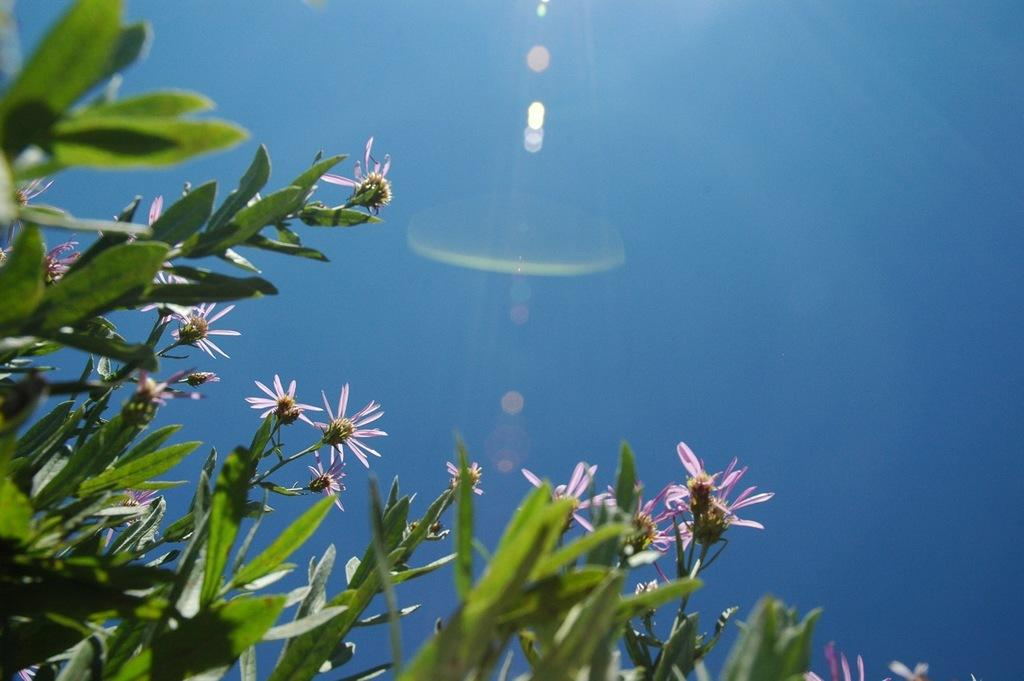What type of plants can be seen in the image? There are plants with flowers in the image. What color are the leaves of the plants? The leaves of the plants are green. What can be seen in the background of the image? There is a blue sky visible in the image. What type of whip is being used by the army in the image? There is no whip or army present in the image; it features plants with flowers and a blue sky. What sense is being stimulated by the image? The image does not stimulate a specific sense, as it is a visual representation of plants and a sky. 